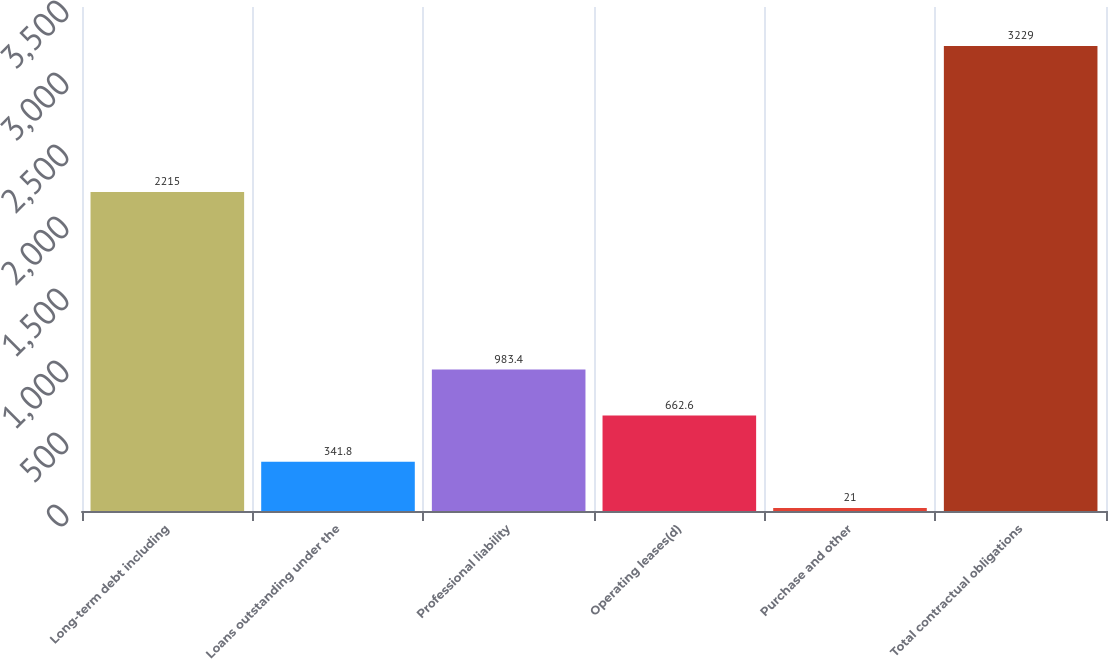Convert chart. <chart><loc_0><loc_0><loc_500><loc_500><bar_chart><fcel>Long-term debt including<fcel>Loans outstanding under the<fcel>Professional liability<fcel>Operating leases(d)<fcel>Purchase and other<fcel>Total contractual obligations<nl><fcel>2215<fcel>341.8<fcel>983.4<fcel>662.6<fcel>21<fcel>3229<nl></chart> 